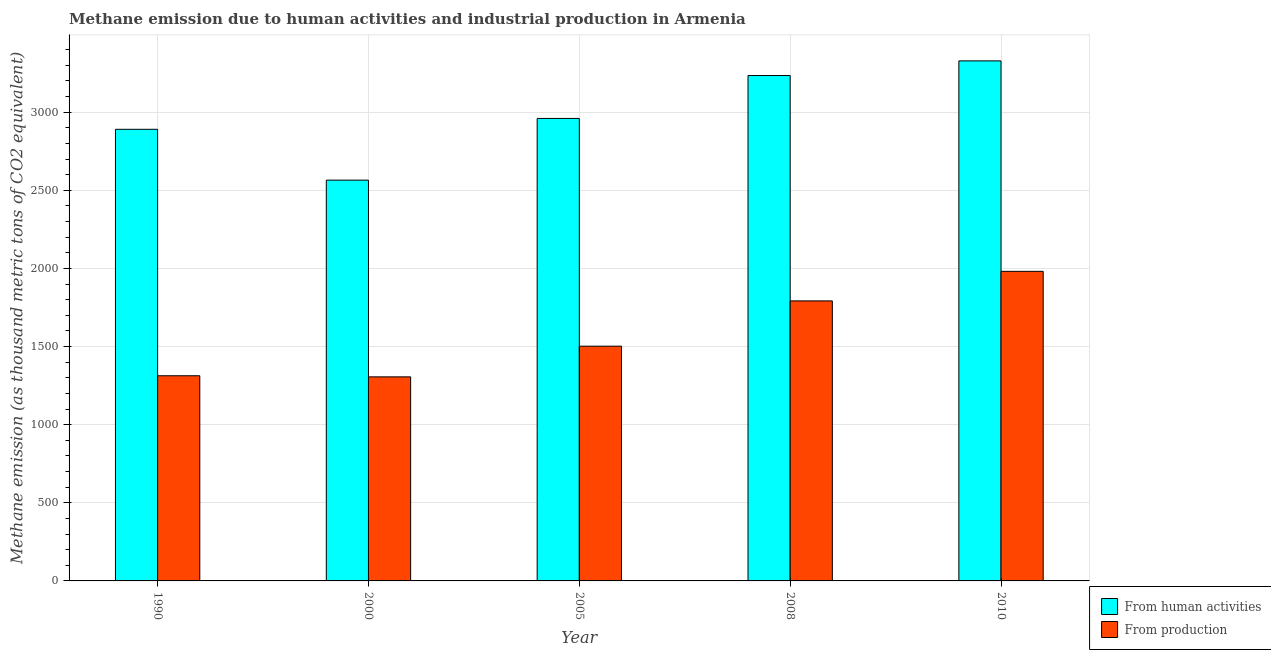How many different coloured bars are there?
Keep it short and to the point. 2. Are the number of bars on each tick of the X-axis equal?
Offer a terse response. Yes. How many bars are there on the 2nd tick from the left?
Provide a short and direct response. 2. What is the label of the 2nd group of bars from the left?
Keep it short and to the point. 2000. What is the amount of emissions from human activities in 2010?
Offer a very short reply. 3328.7. Across all years, what is the maximum amount of emissions generated from industries?
Provide a succinct answer. 1981.6. Across all years, what is the minimum amount of emissions generated from industries?
Offer a very short reply. 1306.1. In which year was the amount of emissions generated from industries minimum?
Your answer should be very brief. 2000. What is the total amount of emissions generated from industries in the graph?
Your answer should be compact. 7895.8. What is the difference between the amount of emissions generated from industries in 1990 and that in 2005?
Your answer should be compact. -189.3. What is the difference between the amount of emissions from human activities in 1990 and the amount of emissions generated from industries in 2010?
Your answer should be very brief. -438. What is the average amount of emissions from human activities per year?
Provide a short and direct response. 2995.98. What is the ratio of the amount of emissions from human activities in 1990 to that in 2000?
Your answer should be very brief. 1.13. What is the difference between the highest and the second highest amount of emissions generated from industries?
Offer a very short reply. 189.2. What is the difference between the highest and the lowest amount of emissions from human activities?
Provide a short and direct response. 763.4. In how many years, is the amount of emissions from human activities greater than the average amount of emissions from human activities taken over all years?
Keep it short and to the point. 2. Is the sum of the amount of emissions from human activities in 2005 and 2010 greater than the maximum amount of emissions generated from industries across all years?
Provide a short and direct response. Yes. What does the 2nd bar from the left in 1990 represents?
Your answer should be compact. From production. What does the 1st bar from the right in 1990 represents?
Your answer should be compact. From production. How many bars are there?
Your response must be concise. 10. Are the values on the major ticks of Y-axis written in scientific E-notation?
Your answer should be very brief. No. Does the graph contain any zero values?
Offer a terse response. No. Does the graph contain grids?
Provide a short and direct response. Yes. Where does the legend appear in the graph?
Provide a succinct answer. Bottom right. How many legend labels are there?
Make the answer very short. 2. What is the title of the graph?
Offer a terse response. Methane emission due to human activities and industrial production in Armenia. What is the label or title of the Y-axis?
Ensure brevity in your answer.  Methane emission (as thousand metric tons of CO2 equivalent). What is the Methane emission (as thousand metric tons of CO2 equivalent) in From human activities in 1990?
Provide a short and direct response. 2890.7. What is the Methane emission (as thousand metric tons of CO2 equivalent) of From production in 1990?
Offer a terse response. 1313.2. What is the Methane emission (as thousand metric tons of CO2 equivalent) in From human activities in 2000?
Your response must be concise. 2565.3. What is the Methane emission (as thousand metric tons of CO2 equivalent) of From production in 2000?
Keep it short and to the point. 1306.1. What is the Methane emission (as thousand metric tons of CO2 equivalent) of From human activities in 2005?
Ensure brevity in your answer.  2960.3. What is the Methane emission (as thousand metric tons of CO2 equivalent) of From production in 2005?
Your response must be concise. 1502.5. What is the Methane emission (as thousand metric tons of CO2 equivalent) in From human activities in 2008?
Offer a terse response. 3234.9. What is the Methane emission (as thousand metric tons of CO2 equivalent) in From production in 2008?
Keep it short and to the point. 1792.4. What is the Methane emission (as thousand metric tons of CO2 equivalent) in From human activities in 2010?
Offer a terse response. 3328.7. What is the Methane emission (as thousand metric tons of CO2 equivalent) in From production in 2010?
Offer a very short reply. 1981.6. Across all years, what is the maximum Methane emission (as thousand metric tons of CO2 equivalent) in From human activities?
Your answer should be compact. 3328.7. Across all years, what is the maximum Methane emission (as thousand metric tons of CO2 equivalent) in From production?
Provide a short and direct response. 1981.6. Across all years, what is the minimum Methane emission (as thousand metric tons of CO2 equivalent) in From human activities?
Provide a short and direct response. 2565.3. Across all years, what is the minimum Methane emission (as thousand metric tons of CO2 equivalent) in From production?
Ensure brevity in your answer.  1306.1. What is the total Methane emission (as thousand metric tons of CO2 equivalent) in From human activities in the graph?
Give a very brief answer. 1.50e+04. What is the total Methane emission (as thousand metric tons of CO2 equivalent) in From production in the graph?
Offer a terse response. 7895.8. What is the difference between the Methane emission (as thousand metric tons of CO2 equivalent) of From human activities in 1990 and that in 2000?
Your response must be concise. 325.4. What is the difference between the Methane emission (as thousand metric tons of CO2 equivalent) of From production in 1990 and that in 2000?
Make the answer very short. 7.1. What is the difference between the Methane emission (as thousand metric tons of CO2 equivalent) of From human activities in 1990 and that in 2005?
Give a very brief answer. -69.6. What is the difference between the Methane emission (as thousand metric tons of CO2 equivalent) of From production in 1990 and that in 2005?
Provide a short and direct response. -189.3. What is the difference between the Methane emission (as thousand metric tons of CO2 equivalent) of From human activities in 1990 and that in 2008?
Provide a short and direct response. -344.2. What is the difference between the Methane emission (as thousand metric tons of CO2 equivalent) of From production in 1990 and that in 2008?
Make the answer very short. -479.2. What is the difference between the Methane emission (as thousand metric tons of CO2 equivalent) of From human activities in 1990 and that in 2010?
Provide a short and direct response. -438. What is the difference between the Methane emission (as thousand metric tons of CO2 equivalent) in From production in 1990 and that in 2010?
Your response must be concise. -668.4. What is the difference between the Methane emission (as thousand metric tons of CO2 equivalent) in From human activities in 2000 and that in 2005?
Offer a very short reply. -395. What is the difference between the Methane emission (as thousand metric tons of CO2 equivalent) in From production in 2000 and that in 2005?
Keep it short and to the point. -196.4. What is the difference between the Methane emission (as thousand metric tons of CO2 equivalent) of From human activities in 2000 and that in 2008?
Ensure brevity in your answer.  -669.6. What is the difference between the Methane emission (as thousand metric tons of CO2 equivalent) in From production in 2000 and that in 2008?
Your answer should be compact. -486.3. What is the difference between the Methane emission (as thousand metric tons of CO2 equivalent) in From human activities in 2000 and that in 2010?
Offer a terse response. -763.4. What is the difference between the Methane emission (as thousand metric tons of CO2 equivalent) in From production in 2000 and that in 2010?
Provide a succinct answer. -675.5. What is the difference between the Methane emission (as thousand metric tons of CO2 equivalent) of From human activities in 2005 and that in 2008?
Provide a short and direct response. -274.6. What is the difference between the Methane emission (as thousand metric tons of CO2 equivalent) in From production in 2005 and that in 2008?
Give a very brief answer. -289.9. What is the difference between the Methane emission (as thousand metric tons of CO2 equivalent) of From human activities in 2005 and that in 2010?
Offer a terse response. -368.4. What is the difference between the Methane emission (as thousand metric tons of CO2 equivalent) of From production in 2005 and that in 2010?
Make the answer very short. -479.1. What is the difference between the Methane emission (as thousand metric tons of CO2 equivalent) in From human activities in 2008 and that in 2010?
Ensure brevity in your answer.  -93.8. What is the difference between the Methane emission (as thousand metric tons of CO2 equivalent) of From production in 2008 and that in 2010?
Provide a succinct answer. -189.2. What is the difference between the Methane emission (as thousand metric tons of CO2 equivalent) in From human activities in 1990 and the Methane emission (as thousand metric tons of CO2 equivalent) in From production in 2000?
Your answer should be compact. 1584.6. What is the difference between the Methane emission (as thousand metric tons of CO2 equivalent) of From human activities in 1990 and the Methane emission (as thousand metric tons of CO2 equivalent) of From production in 2005?
Provide a succinct answer. 1388.2. What is the difference between the Methane emission (as thousand metric tons of CO2 equivalent) of From human activities in 1990 and the Methane emission (as thousand metric tons of CO2 equivalent) of From production in 2008?
Ensure brevity in your answer.  1098.3. What is the difference between the Methane emission (as thousand metric tons of CO2 equivalent) of From human activities in 1990 and the Methane emission (as thousand metric tons of CO2 equivalent) of From production in 2010?
Offer a terse response. 909.1. What is the difference between the Methane emission (as thousand metric tons of CO2 equivalent) of From human activities in 2000 and the Methane emission (as thousand metric tons of CO2 equivalent) of From production in 2005?
Offer a terse response. 1062.8. What is the difference between the Methane emission (as thousand metric tons of CO2 equivalent) of From human activities in 2000 and the Methane emission (as thousand metric tons of CO2 equivalent) of From production in 2008?
Make the answer very short. 772.9. What is the difference between the Methane emission (as thousand metric tons of CO2 equivalent) of From human activities in 2000 and the Methane emission (as thousand metric tons of CO2 equivalent) of From production in 2010?
Give a very brief answer. 583.7. What is the difference between the Methane emission (as thousand metric tons of CO2 equivalent) in From human activities in 2005 and the Methane emission (as thousand metric tons of CO2 equivalent) in From production in 2008?
Your answer should be very brief. 1167.9. What is the difference between the Methane emission (as thousand metric tons of CO2 equivalent) of From human activities in 2005 and the Methane emission (as thousand metric tons of CO2 equivalent) of From production in 2010?
Your answer should be very brief. 978.7. What is the difference between the Methane emission (as thousand metric tons of CO2 equivalent) of From human activities in 2008 and the Methane emission (as thousand metric tons of CO2 equivalent) of From production in 2010?
Offer a terse response. 1253.3. What is the average Methane emission (as thousand metric tons of CO2 equivalent) in From human activities per year?
Provide a short and direct response. 2995.98. What is the average Methane emission (as thousand metric tons of CO2 equivalent) in From production per year?
Ensure brevity in your answer.  1579.16. In the year 1990, what is the difference between the Methane emission (as thousand metric tons of CO2 equivalent) in From human activities and Methane emission (as thousand metric tons of CO2 equivalent) in From production?
Make the answer very short. 1577.5. In the year 2000, what is the difference between the Methane emission (as thousand metric tons of CO2 equivalent) of From human activities and Methane emission (as thousand metric tons of CO2 equivalent) of From production?
Your answer should be very brief. 1259.2. In the year 2005, what is the difference between the Methane emission (as thousand metric tons of CO2 equivalent) of From human activities and Methane emission (as thousand metric tons of CO2 equivalent) of From production?
Keep it short and to the point. 1457.8. In the year 2008, what is the difference between the Methane emission (as thousand metric tons of CO2 equivalent) in From human activities and Methane emission (as thousand metric tons of CO2 equivalent) in From production?
Offer a very short reply. 1442.5. In the year 2010, what is the difference between the Methane emission (as thousand metric tons of CO2 equivalent) in From human activities and Methane emission (as thousand metric tons of CO2 equivalent) in From production?
Offer a terse response. 1347.1. What is the ratio of the Methane emission (as thousand metric tons of CO2 equivalent) in From human activities in 1990 to that in 2000?
Offer a very short reply. 1.13. What is the ratio of the Methane emission (as thousand metric tons of CO2 equivalent) of From production in 1990 to that in 2000?
Ensure brevity in your answer.  1.01. What is the ratio of the Methane emission (as thousand metric tons of CO2 equivalent) of From human activities in 1990 to that in 2005?
Ensure brevity in your answer.  0.98. What is the ratio of the Methane emission (as thousand metric tons of CO2 equivalent) in From production in 1990 to that in 2005?
Provide a succinct answer. 0.87. What is the ratio of the Methane emission (as thousand metric tons of CO2 equivalent) in From human activities in 1990 to that in 2008?
Provide a succinct answer. 0.89. What is the ratio of the Methane emission (as thousand metric tons of CO2 equivalent) of From production in 1990 to that in 2008?
Your response must be concise. 0.73. What is the ratio of the Methane emission (as thousand metric tons of CO2 equivalent) in From human activities in 1990 to that in 2010?
Keep it short and to the point. 0.87. What is the ratio of the Methane emission (as thousand metric tons of CO2 equivalent) in From production in 1990 to that in 2010?
Provide a short and direct response. 0.66. What is the ratio of the Methane emission (as thousand metric tons of CO2 equivalent) of From human activities in 2000 to that in 2005?
Offer a very short reply. 0.87. What is the ratio of the Methane emission (as thousand metric tons of CO2 equivalent) of From production in 2000 to that in 2005?
Ensure brevity in your answer.  0.87. What is the ratio of the Methane emission (as thousand metric tons of CO2 equivalent) in From human activities in 2000 to that in 2008?
Make the answer very short. 0.79. What is the ratio of the Methane emission (as thousand metric tons of CO2 equivalent) of From production in 2000 to that in 2008?
Make the answer very short. 0.73. What is the ratio of the Methane emission (as thousand metric tons of CO2 equivalent) in From human activities in 2000 to that in 2010?
Ensure brevity in your answer.  0.77. What is the ratio of the Methane emission (as thousand metric tons of CO2 equivalent) of From production in 2000 to that in 2010?
Offer a very short reply. 0.66. What is the ratio of the Methane emission (as thousand metric tons of CO2 equivalent) in From human activities in 2005 to that in 2008?
Offer a very short reply. 0.92. What is the ratio of the Methane emission (as thousand metric tons of CO2 equivalent) of From production in 2005 to that in 2008?
Ensure brevity in your answer.  0.84. What is the ratio of the Methane emission (as thousand metric tons of CO2 equivalent) of From human activities in 2005 to that in 2010?
Provide a succinct answer. 0.89. What is the ratio of the Methane emission (as thousand metric tons of CO2 equivalent) in From production in 2005 to that in 2010?
Make the answer very short. 0.76. What is the ratio of the Methane emission (as thousand metric tons of CO2 equivalent) of From human activities in 2008 to that in 2010?
Give a very brief answer. 0.97. What is the ratio of the Methane emission (as thousand metric tons of CO2 equivalent) of From production in 2008 to that in 2010?
Offer a very short reply. 0.9. What is the difference between the highest and the second highest Methane emission (as thousand metric tons of CO2 equivalent) of From human activities?
Provide a succinct answer. 93.8. What is the difference between the highest and the second highest Methane emission (as thousand metric tons of CO2 equivalent) of From production?
Keep it short and to the point. 189.2. What is the difference between the highest and the lowest Methane emission (as thousand metric tons of CO2 equivalent) in From human activities?
Provide a short and direct response. 763.4. What is the difference between the highest and the lowest Methane emission (as thousand metric tons of CO2 equivalent) of From production?
Make the answer very short. 675.5. 